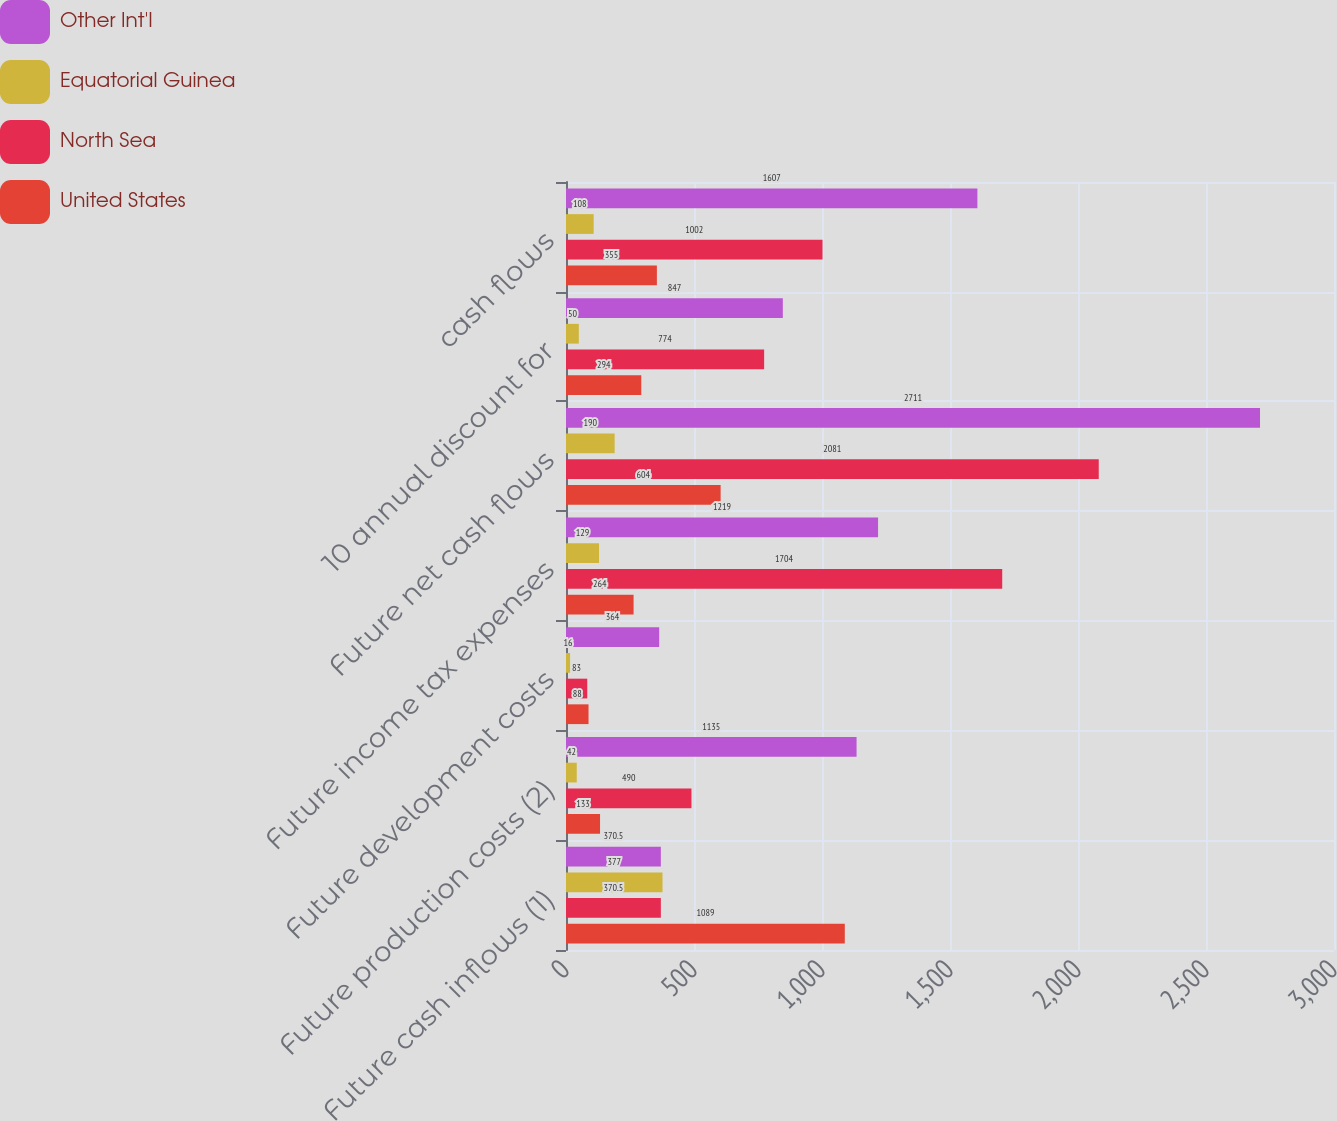Convert chart to OTSL. <chart><loc_0><loc_0><loc_500><loc_500><stacked_bar_chart><ecel><fcel>Future cash inflows (1)<fcel>Future production costs (2)<fcel>Future development costs<fcel>Future income tax expenses<fcel>Future net cash flows<fcel>10 annual discount for<fcel>cash flows<nl><fcel>Other Int'l<fcel>370.5<fcel>1135<fcel>364<fcel>1219<fcel>2711<fcel>847<fcel>1607<nl><fcel>Equatorial Guinea<fcel>377<fcel>42<fcel>16<fcel>129<fcel>190<fcel>50<fcel>108<nl><fcel>North Sea<fcel>370.5<fcel>490<fcel>83<fcel>1704<fcel>2081<fcel>774<fcel>1002<nl><fcel>United States<fcel>1089<fcel>133<fcel>88<fcel>264<fcel>604<fcel>294<fcel>355<nl></chart> 